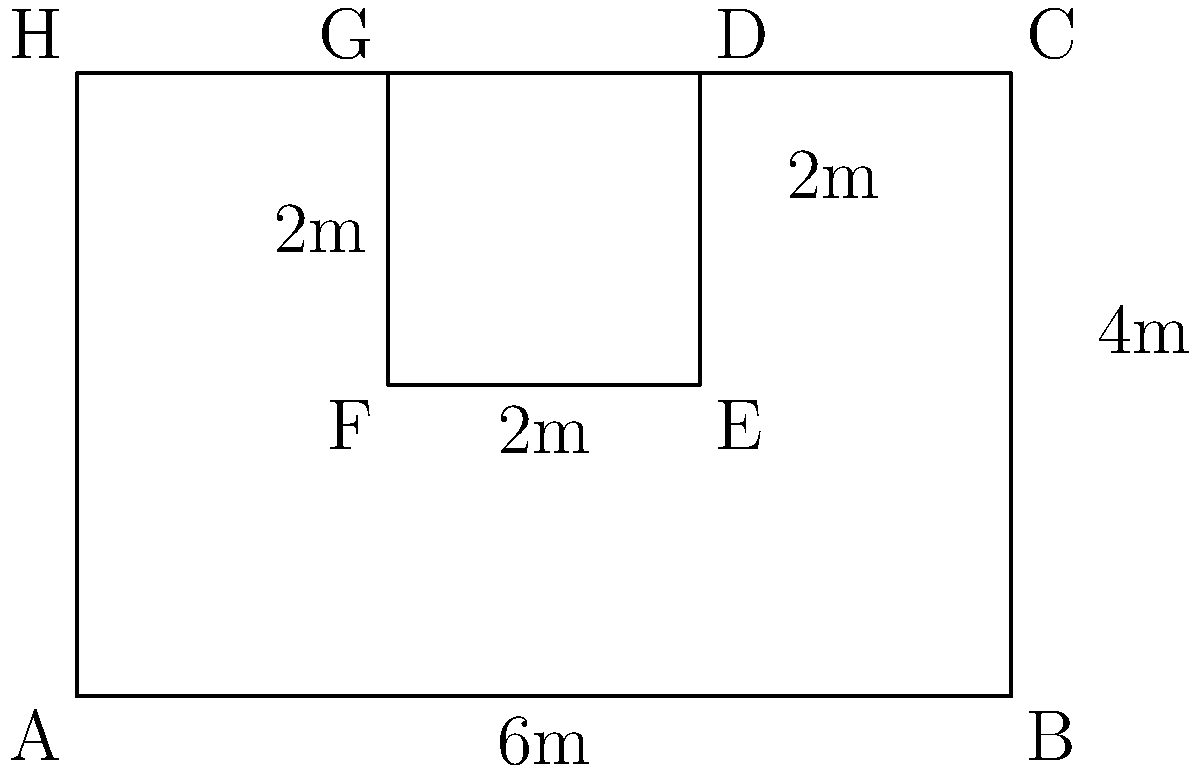As part of your Broadway theater feature, you're investigating the backstage area of a historic theater. The diagram shows the layout of interconnected dressing rooms. If each line represents a wall, what is the total perimeter of the entire dressing room area? Assume all unmarked segments have lengths that can be deduced from the given measurements. To calculate the total perimeter, we need to sum up the lengths of all exterior walls:

1. Bottom wall: $6$ m
2. Right wall: $4$ m
3. Top wall: $6$ m (same as bottom)
4. Left wall: $4$ m (same as right)

Total perimeter = $6 + 4 + 6 + 4 = 20$ m

Note: The internal walls (D-G and E-F) are not part of the perimeter calculation as they are inside the overall shape.

This problem illustrates how theater architecture often maximizes space usage while maintaining a simple exterior structure, which is an interesting point for a journalist writing about Broadway history and design.
Answer: $20$ m 